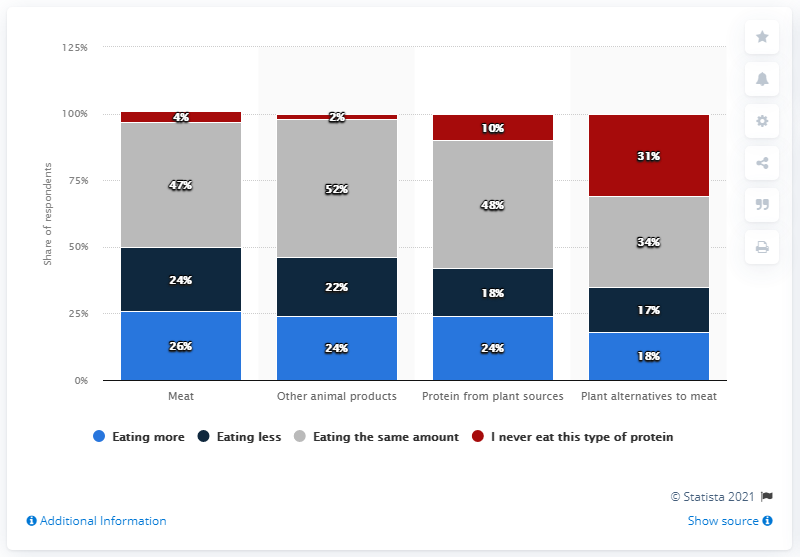Point out several critical features in this image. During the COVID-19 pandemic, many individuals claimed to have changed their consumption of meat as a protein source. It is likely that this change in consumption was due to health concerns and the government's recommendations for reducing personal contact. 